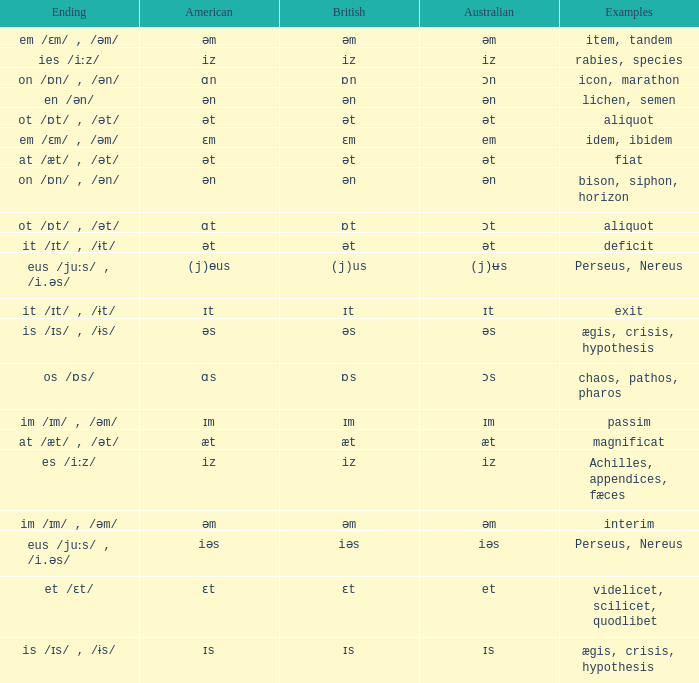Which Examples has Australian of əm? Item, tandem, interim. 